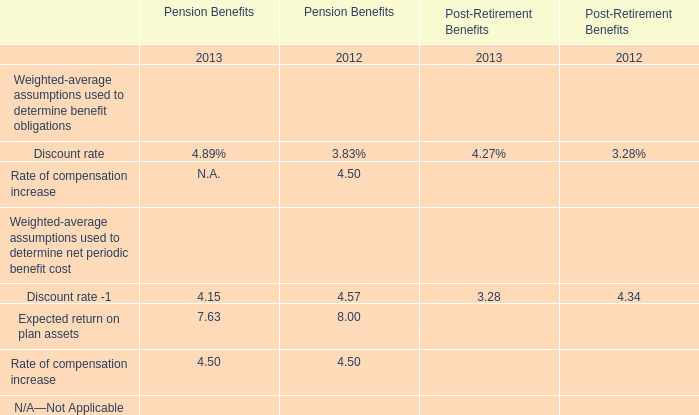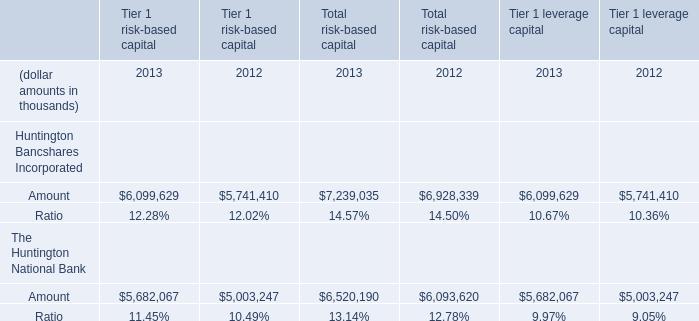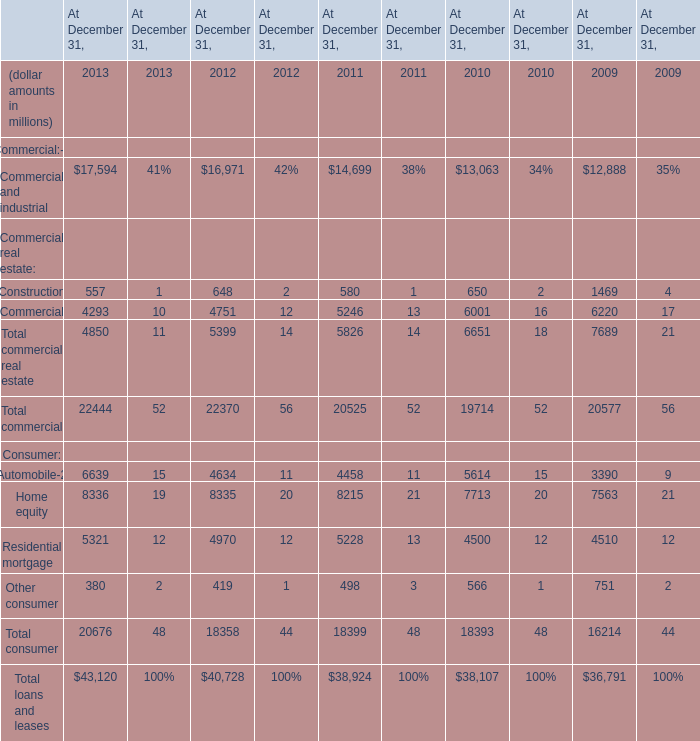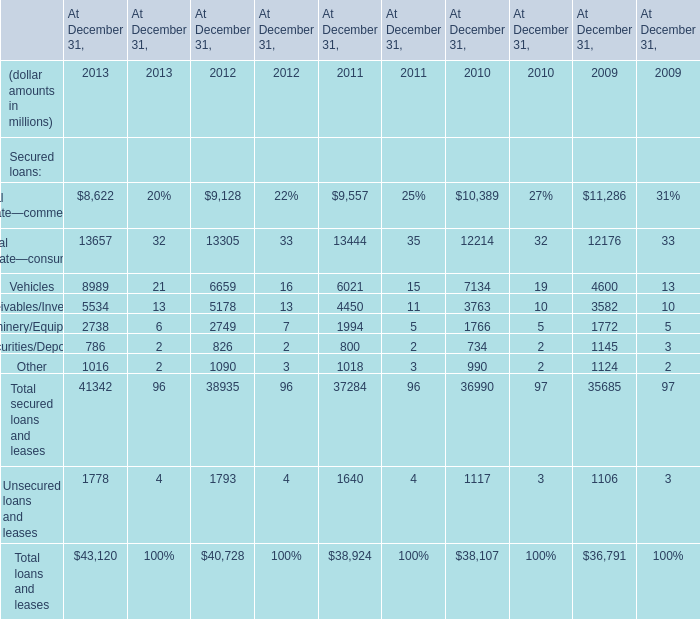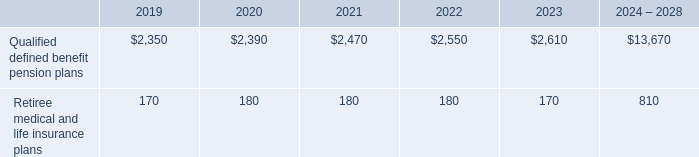what is the percentage change in 401 ( k ) contributions from 2017 to 2018? 
Computations: ((658 - 613) / 613)
Answer: 0.07341. 